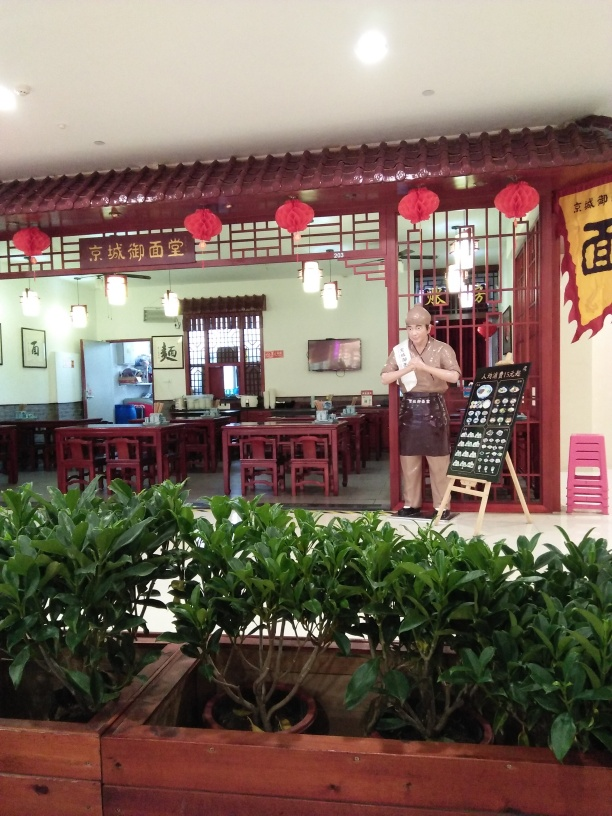How would you describe the decor and layout of the shop? The decor is traditional and cultural, featuring wood-paneled walls, lattice window frames, and hanging red lanterns that give a festive feel. The layout includes neatly arranged tables that provide ample dining space, with greenery adding a touch of freshness to the environment. 